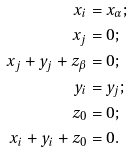Convert formula to latex. <formula><loc_0><loc_0><loc_500><loc_500>x _ { i } & = x _ { \alpha } ; \\ x _ { j } & = 0 ; \\ x _ { j } + y _ { j } + z _ { \beta } & = 0 ; \\ y _ { i } & = y _ { j } ; \\ z _ { 0 } & = 0 ; \\ x _ { i } + y _ { i } + z _ { 0 } & = 0 .</formula> 